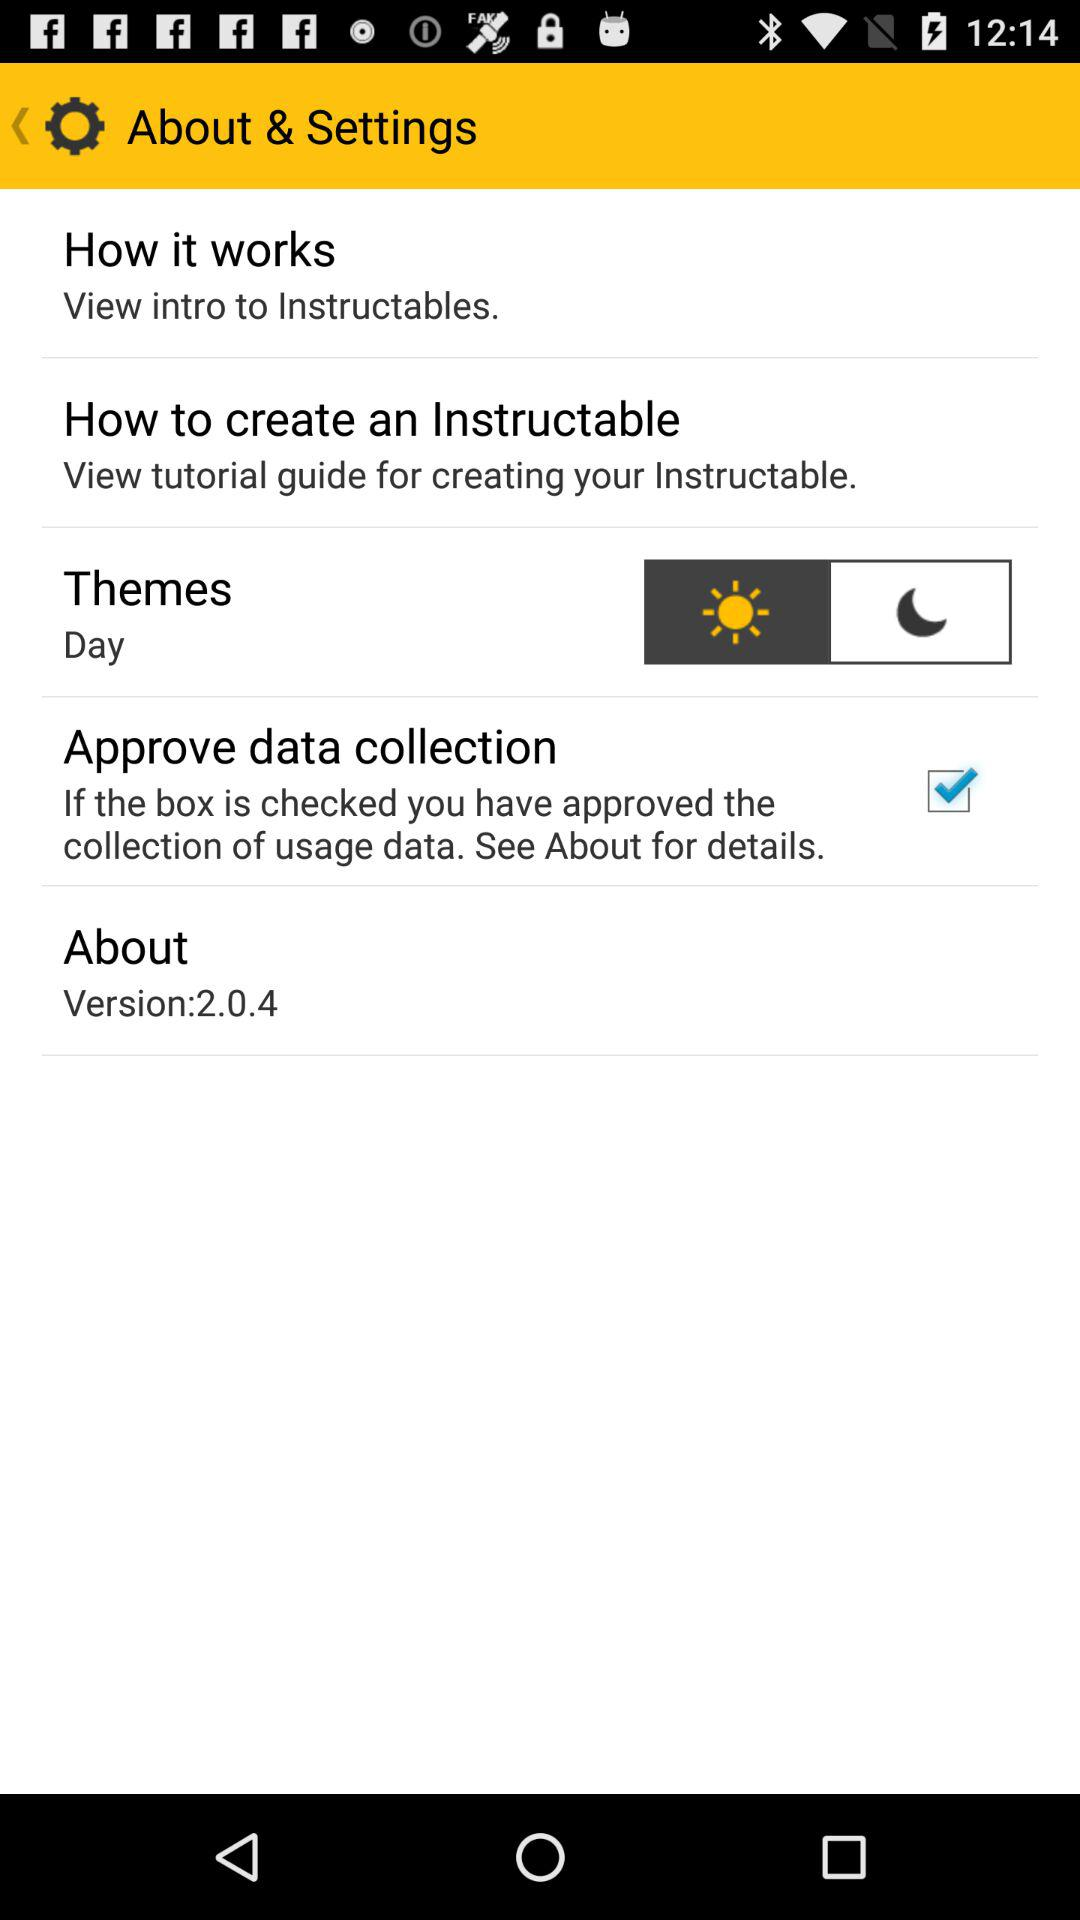Which version is used? The used version is 2.0.4. 